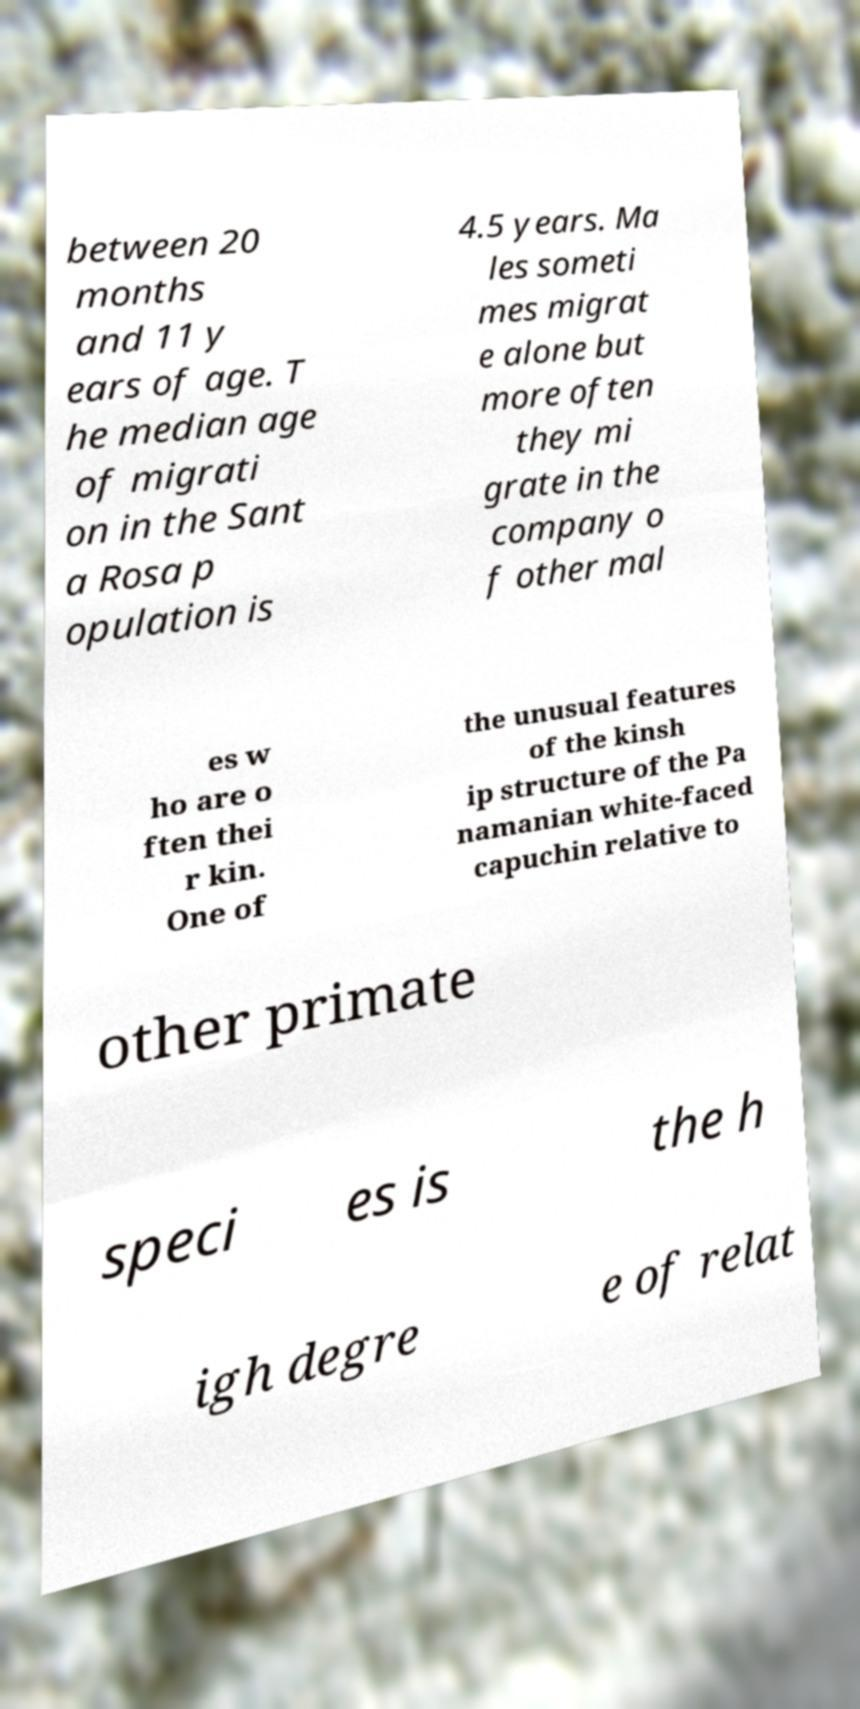I need the written content from this picture converted into text. Can you do that? between 20 months and 11 y ears of age. T he median age of migrati on in the Sant a Rosa p opulation is 4.5 years. Ma les someti mes migrat e alone but more often they mi grate in the company o f other mal es w ho are o ften thei r kin. One of the unusual features of the kinsh ip structure of the Pa namanian white-faced capuchin relative to other primate speci es is the h igh degre e of relat 